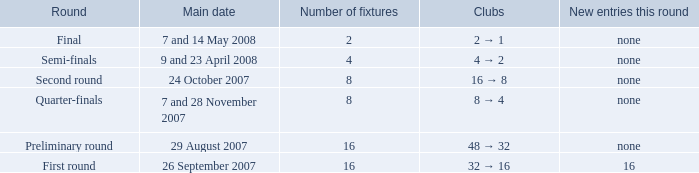What is the sum of Number of fixtures when the rounds shows quarter-finals? 8.0. 